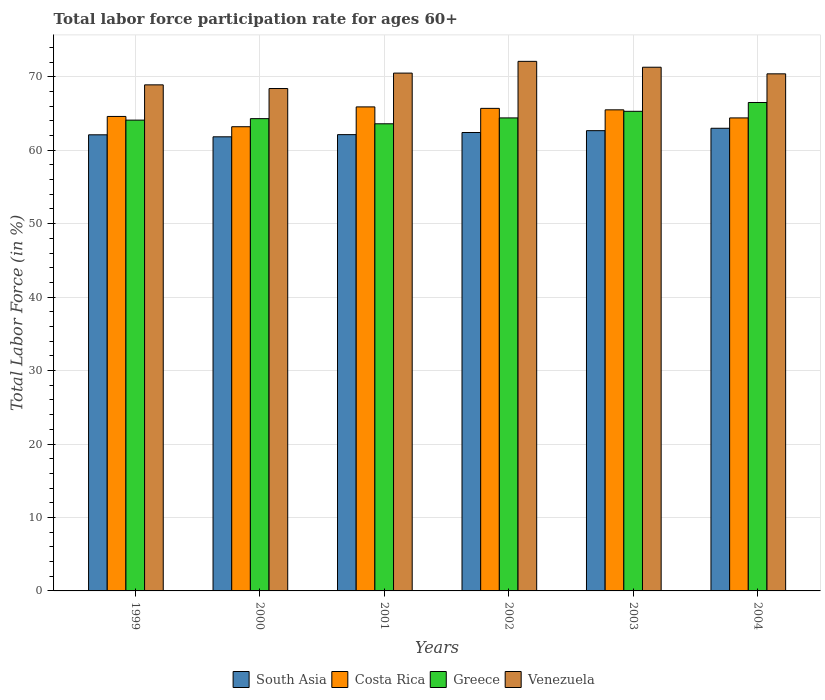Are the number of bars on each tick of the X-axis equal?
Provide a short and direct response. Yes. How many bars are there on the 6th tick from the left?
Your answer should be compact. 4. In how many cases, is the number of bars for a given year not equal to the number of legend labels?
Your answer should be very brief. 0. What is the labor force participation rate in South Asia in 2003?
Your response must be concise. 62.66. Across all years, what is the maximum labor force participation rate in Venezuela?
Your answer should be compact. 72.1. Across all years, what is the minimum labor force participation rate in Costa Rica?
Provide a short and direct response. 63.2. What is the total labor force participation rate in Greece in the graph?
Ensure brevity in your answer.  388.2. What is the difference between the labor force participation rate in South Asia in 2001 and that in 2004?
Ensure brevity in your answer.  -0.87. What is the difference between the labor force participation rate in Greece in 2000 and the labor force participation rate in Venezuela in 2002?
Your answer should be compact. -7.8. What is the average labor force participation rate in South Asia per year?
Offer a very short reply. 62.35. In the year 2004, what is the difference between the labor force participation rate in South Asia and labor force participation rate in Costa Rica?
Make the answer very short. -1.41. In how many years, is the labor force participation rate in Costa Rica greater than 36 %?
Provide a short and direct response. 6. What is the ratio of the labor force participation rate in South Asia in 2001 to that in 2002?
Your answer should be very brief. 1. Is the labor force participation rate in Costa Rica in 2002 less than that in 2003?
Offer a terse response. No. What is the difference between the highest and the second highest labor force participation rate in South Asia?
Give a very brief answer. 0.33. What is the difference between the highest and the lowest labor force participation rate in Costa Rica?
Give a very brief answer. 2.7. In how many years, is the labor force participation rate in Greece greater than the average labor force participation rate in Greece taken over all years?
Keep it short and to the point. 2. Is the sum of the labor force participation rate in South Asia in 2001 and 2003 greater than the maximum labor force participation rate in Costa Rica across all years?
Your answer should be compact. Yes. What does the 4th bar from the left in 2003 represents?
Ensure brevity in your answer.  Venezuela. What does the 1st bar from the right in 2003 represents?
Give a very brief answer. Venezuela. Are all the bars in the graph horizontal?
Your answer should be compact. No. How many years are there in the graph?
Your answer should be very brief. 6. Are the values on the major ticks of Y-axis written in scientific E-notation?
Give a very brief answer. No. Does the graph contain any zero values?
Ensure brevity in your answer.  No. Where does the legend appear in the graph?
Offer a very short reply. Bottom center. What is the title of the graph?
Make the answer very short. Total labor force participation rate for ages 60+. What is the label or title of the X-axis?
Keep it short and to the point. Years. What is the label or title of the Y-axis?
Offer a very short reply. Total Labor Force (in %). What is the Total Labor Force (in %) in South Asia in 1999?
Your response must be concise. 62.1. What is the Total Labor Force (in %) of Costa Rica in 1999?
Give a very brief answer. 64.6. What is the Total Labor Force (in %) in Greece in 1999?
Offer a terse response. 64.1. What is the Total Labor Force (in %) in Venezuela in 1999?
Provide a short and direct response. 68.9. What is the Total Labor Force (in %) of South Asia in 2000?
Your answer should be very brief. 61.83. What is the Total Labor Force (in %) in Costa Rica in 2000?
Make the answer very short. 63.2. What is the Total Labor Force (in %) in Greece in 2000?
Keep it short and to the point. 64.3. What is the Total Labor Force (in %) of Venezuela in 2000?
Your answer should be very brief. 68.4. What is the Total Labor Force (in %) of South Asia in 2001?
Keep it short and to the point. 62.12. What is the Total Labor Force (in %) of Costa Rica in 2001?
Ensure brevity in your answer.  65.9. What is the Total Labor Force (in %) of Greece in 2001?
Keep it short and to the point. 63.6. What is the Total Labor Force (in %) in Venezuela in 2001?
Offer a terse response. 70.5. What is the Total Labor Force (in %) in South Asia in 2002?
Offer a terse response. 62.41. What is the Total Labor Force (in %) of Costa Rica in 2002?
Offer a very short reply. 65.7. What is the Total Labor Force (in %) in Greece in 2002?
Offer a very short reply. 64.4. What is the Total Labor Force (in %) in Venezuela in 2002?
Provide a succinct answer. 72.1. What is the Total Labor Force (in %) of South Asia in 2003?
Offer a very short reply. 62.66. What is the Total Labor Force (in %) in Costa Rica in 2003?
Your answer should be compact. 65.5. What is the Total Labor Force (in %) in Greece in 2003?
Keep it short and to the point. 65.3. What is the Total Labor Force (in %) in Venezuela in 2003?
Make the answer very short. 71.3. What is the Total Labor Force (in %) in South Asia in 2004?
Give a very brief answer. 62.99. What is the Total Labor Force (in %) of Costa Rica in 2004?
Provide a succinct answer. 64.4. What is the Total Labor Force (in %) of Greece in 2004?
Ensure brevity in your answer.  66.5. What is the Total Labor Force (in %) of Venezuela in 2004?
Provide a short and direct response. 70.4. Across all years, what is the maximum Total Labor Force (in %) in South Asia?
Offer a terse response. 62.99. Across all years, what is the maximum Total Labor Force (in %) of Costa Rica?
Ensure brevity in your answer.  65.9. Across all years, what is the maximum Total Labor Force (in %) in Greece?
Offer a terse response. 66.5. Across all years, what is the maximum Total Labor Force (in %) in Venezuela?
Ensure brevity in your answer.  72.1. Across all years, what is the minimum Total Labor Force (in %) of South Asia?
Your answer should be very brief. 61.83. Across all years, what is the minimum Total Labor Force (in %) in Costa Rica?
Give a very brief answer. 63.2. Across all years, what is the minimum Total Labor Force (in %) of Greece?
Ensure brevity in your answer.  63.6. Across all years, what is the minimum Total Labor Force (in %) of Venezuela?
Provide a short and direct response. 68.4. What is the total Total Labor Force (in %) in South Asia in the graph?
Make the answer very short. 374.11. What is the total Total Labor Force (in %) of Costa Rica in the graph?
Provide a succinct answer. 389.3. What is the total Total Labor Force (in %) in Greece in the graph?
Provide a succinct answer. 388.2. What is the total Total Labor Force (in %) of Venezuela in the graph?
Provide a succinct answer. 421.6. What is the difference between the Total Labor Force (in %) in South Asia in 1999 and that in 2000?
Ensure brevity in your answer.  0.27. What is the difference between the Total Labor Force (in %) in Venezuela in 1999 and that in 2000?
Your response must be concise. 0.5. What is the difference between the Total Labor Force (in %) of South Asia in 1999 and that in 2001?
Give a very brief answer. -0.02. What is the difference between the Total Labor Force (in %) in Venezuela in 1999 and that in 2001?
Keep it short and to the point. -1.6. What is the difference between the Total Labor Force (in %) in South Asia in 1999 and that in 2002?
Provide a short and direct response. -0.31. What is the difference between the Total Labor Force (in %) of Costa Rica in 1999 and that in 2002?
Your answer should be compact. -1.1. What is the difference between the Total Labor Force (in %) in Greece in 1999 and that in 2002?
Offer a very short reply. -0.3. What is the difference between the Total Labor Force (in %) in South Asia in 1999 and that in 2003?
Provide a succinct answer. -0.56. What is the difference between the Total Labor Force (in %) in Venezuela in 1999 and that in 2003?
Provide a short and direct response. -2.4. What is the difference between the Total Labor Force (in %) of South Asia in 1999 and that in 2004?
Give a very brief answer. -0.89. What is the difference between the Total Labor Force (in %) in Costa Rica in 1999 and that in 2004?
Offer a terse response. 0.2. What is the difference between the Total Labor Force (in %) of South Asia in 2000 and that in 2001?
Your answer should be very brief. -0.3. What is the difference between the Total Labor Force (in %) of Venezuela in 2000 and that in 2001?
Provide a short and direct response. -2.1. What is the difference between the Total Labor Force (in %) in South Asia in 2000 and that in 2002?
Provide a succinct answer. -0.59. What is the difference between the Total Labor Force (in %) of Costa Rica in 2000 and that in 2002?
Your answer should be very brief. -2.5. What is the difference between the Total Labor Force (in %) of Greece in 2000 and that in 2002?
Provide a succinct answer. -0.1. What is the difference between the Total Labor Force (in %) in Venezuela in 2000 and that in 2002?
Keep it short and to the point. -3.7. What is the difference between the Total Labor Force (in %) in South Asia in 2000 and that in 2003?
Offer a very short reply. -0.84. What is the difference between the Total Labor Force (in %) in Costa Rica in 2000 and that in 2003?
Provide a short and direct response. -2.3. What is the difference between the Total Labor Force (in %) of Venezuela in 2000 and that in 2003?
Your answer should be very brief. -2.9. What is the difference between the Total Labor Force (in %) in South Asia in 2000 and that in 2004?
Your response must be concise. -1.16. What is the difference between the Total Labor Force (in %) of Costa Rica in 2000 and that in 2004?
Give a very brief answer. -1.2. What is the difference between the Total Labor Force (in %) of South Asia in 2001 and that in 2002?
Make the answer very short. -0.29. What is the difference between the Total Labor Force (in %) in Greece in 2001 and that in 2002?
Make the answer very short. -0.8. What is the difference between the Total Labor Force (in %) of Venezuela in 2001 and that in 2002?
Provide a short and direct response. -1.6. What is the difference between the Total Labor Force (in %) of South Asia in 2001 and that in 2003?
Offer a very short reply. -0.54. What is the difference between the Total Labor Force (in %) in Greece in 2001 and that in 2003?
Your answer should be compact. -1.7. What is the difference between the Total Labor Force (in %) in Venezuela in 2001 and that in 2003?
Provide a short and direct response. -0.8. What is the difference between the Total Labor Force (in %) in South Asia in 2001 and that in 2004?
Keep it short and to the point. -0.87. What is the difference between the Total Labor Force (in %) of Costa Rica in 2001 and that in 2004?
Your answer should be compact. 1.5. What is the difference between the Total Labor Force (in %) in Venezuela in 2001 and that in 2004?
Your response must be concise. 0.1. What is the difference between the Total Labor Force (in %) of South Asia in 2002 and that in 2003?
Your answer should be compact. -0.25. What is the difference between the Total Labor Force (in %) in Venezuela in 2002 and that in 2003?
Provide a short and direct response. 0.8. What is the difference between the Total Labor Force (in %) of South Asia in 2002 and that in 2004?
Your answer should be very brief. -0.57. What is the difference between the Total Labor Force (in %) of Greece in 2002 and that in 2004?
Give a very brief answer. -2.1. What is the difference between the Total Labor Force (in %) in Venezuela in 2002 and that in 2004?
Your answer should be very brief. 1.7. What is the difference between the Total Labor Force (in %) of South Asia in 2003 and that in 2004?
Ensure brevity in your answer.  -0.33. What is the difference between the Total Labor Force (in %) of Costa Rica in 2003 and that in 2004?
Keep it short and to the point. 1.1. What is the difference between the Total Labor Force (in %) of South Asia in 1999 and the Total Labor Force (in %) of Costa Rica in 2000?
Keep it short and to the point. -1.1. What is the difference between the Total Labor Force (in %) of South Asia in 1999 and the Total Labor Force (in %) of Greece in 2000?
Keep it short and to the point. -2.2. What is the difference between the Total Labor Force (in %) of South Asia in 1999 and the Total Labor Force (in %) of Venezuela in 2000?
Make the answer very short. -6.3. What is the difference between the Total Labor Force (in %) in Costa Rica in 1999 and the Total Labor Force (in %) in Venezuela in 2000?
Offer a terse response. -3.8. What is the difference between the Total Labor Force (in %) of Greece in 1999 and the Total Labor Force (in %) of Venezuela in 2000?
Your answer should be very brief. -4.3. What is the difference between the Total Labor Force (in %) of South Asia in 1999 and the Total Labor Force (in %) of Costa Rica in 2001?
Ensure brevity in your answer.  -3.8. What is the difference between the Total Labor Force (in %) in South Asia in 1999 and the Total Labor Force (in %) in Greece in 2001?
Offer a terse response. -1.5. What is the difference between the Total Labor Force (in %) in South Asia in 1999 and the Total Labor Force (in %) in Venezuela in 2001?
Keep it short and to the point. -8.4. What is the difference between the Total Labor Force (in %) of Costa Rica in 1999 and the Total Labor Force (in %) of Venezuela in 2001?
Your response must be concise. -5.9. What is the difference between the Total Labor Force (in %) in Greece in 1999 and the Total Labor Force (in %) in Venezuela in 2001?
Ensure brevity in your answer.  -6.4. What is the difference between the Total Labor Force (in %) in South Asia in 1999 and the Total Labor Force (in %) in Costa Rica in 2002?
Offer a very short reply. -3.6. What is the difference between the Total Labor Force (in %) of South Asia in 1999 and the Total Labor Force (in %) of Greece in 2002?
Make the answer very short. -2.3. What is the difference between the Total Labor Force (in %) of South Asia in 1999 and the Total Labor Force (in %) of Venezuela in 2002?
Provide a succinct answer. -10. What is the difference between the Total Labor Force (in %) of South Asia in 1999 and the Total Labor Force (in %) of Costa Rica in 2003?
Provide a short and direct response. -3.4. What is the difference between the Total Labor Force (in %) of South Asia in 1999 and the Total Labor Force (in %) of Greece in 2003?
Offer a terse response. -3.2. What is the difference between the Total Labor Force (in %) in South Asia in 1999 and the Total Labor Force (in %) in Venezuela in 2003?
Your answer should be compact. -9.2. What is the difference between the Total Labor Force (in %) in South Asia in 1999 and the Total Labor Force (in %) in Costa Rica in 2004?
Offer a terse response. -2.3. What is the difference between the Total Labor Force (in %) of South Asia in 1999 and the Total Labor Force (in %) of Greece in 2004?
Give a very brief answer. -4.4. What is the difference between the Total Labor Force (in %) in South Asia in 1999 and the Total Labor Force (in %) in Venezuela in 2004?
Offer a terse response. -8.3. What is the difference between the Total Labor Force (in %) of Costa Rica in 1999 and the Total Labor Force (in %) of Greece in 2004?
Your answer should be very brief. -1.9. What is the difference between the Total Labor Force (in %) of Costa Rica in 1999 and the Total Labor Force (in %) of Venezuela in 2004?
Ensure brevity in your answer.  -5.8. What is the difference between the Total Labor Force (in %) in Greece in 1999 and the Total Labor Force (in %) in Venezuela in 2004?
Your answer should be very brief. -6.3. What is the difference between the Total Labor Force (in %) in South Asia in 2000 and the Total Labor Force (in %) in Costa Rica in 2001?
Make the answer very short. -4.07. What is the difference between the Total Labor Force (in %) of South Asia in 2000 and the Total Labor Force (in %) of Greece in 2001?
Provide a short and direct response. -1.77. What is the difference between the Total Labor Force (in %) in South Asia in 2000 and the Total Labor Force (in %) in Venezuela in 2001?
Offer a terse response. -8.67. What is the difference between the Total Labor Force (in %) in Costa Rica in 2000 and the Total Labor Force (in %) in Greece in 2001?
Provide a succinct answer. -0.4. What is the difference between the Total Labor Force (in %) in Costa Rica in 2000 and the Total Labor Force (in %) in Venezuela in 2001?
Offer a very short reply. -7.3. What is the difference between the Total Labor Force (in %) of South Asia in 2000 and the Total Labor Force (in %) of Costa Rica in 2002?
Offer a terse response. -3.87. What is the difference between the Total Labor Force (in %) in South Asia in 2000 and the Total Labor Force (in %) in Greece in 2002?
Your answer should be very brief. -2.57. What is the difference between the Total Labor Force (in %) in South Asia in 2000 and the Total Labor Force (in %) in Venezuela in 2002?
Your answer should be compact. -10.27. What is the difference between the Total Labor Force (in %) in Costa Rica in 2000 and the Total Labor Force (in %) in Greece in 2002?
Ensure brevity in your answer.  -1.2. What is the difference between the Total Labor Force (in %) of Costa Rica in 2000 and the Total Labor Force (in %) of Venezuela in 2002?
Offer a terse response. -8.9. What is the difference between the Total Labor Force (in %) in South Asia in 2000 and the Total Labor Force (in %) in Costa Rica in 2003?
Offer a terse response. -3.67. What is the difference between the Total Labor Force (in %) in South Asia in 2000 and the Total Labor Force (in %) in Greece in 2003?
Ensure brevity in your answer.  -3.47. What is the difference between the Total Labor Force (in %) in South Asia in 2000 and the Total Labor Force (in %) in Venezuela in 2003?
Your answer should be very brief. -9.47. What is the difference between the Total Labor Force (in %) of Costa Rica in 2000 and the Total Labor Force (in %) of Greece in 2003?
Offer a very short reply. -2.1. What is the difference between the Total Labor Force (in %) of Greece in 2000 and the Total Labor Force (in %) of Venezuela in 2003?
Offer a very short reply. -7. What is the difference between the Total Labor Force (in %) of South Asia in 2000 and the Total Labor Force (in %) of Costa Rica in 2004?
Make the answer very short. -2.57. What is the difference between the Total Labor Force (in %) in South Asia in 2000 and the Total Labor Force (in %) in Greece in 2004?
Keep it short and to the point. -4.67. What is the difference between the Total Labor Force (in %) of South Asia in 2000 and the Total Labor Force (in %) of Venezuela in 2004?
Your response must be concise. -8.57. What is the difference between the Total Labor Force (in %) of Greece in 2000 and the Total Labor Force (in %) of Venezuela in 2004?
Offer a very short reply. -6.1. What is the difference between the Total Labor Force (in %) in South Asia in 2001 and the Total Labor Force (in %) in Costa Rica in 2002?
Keep it short and to the point. -3.58. What is the difference between the Total Labor Force (in %) in South Asia in 2001 and the Total Labor Force (in %) in Greece in 2002?
Make the answer very short. -2.28. What is the difference between the Total Labor Force (in %) in South Asia in 2001 and the Total Labor Force (in %) in Venezuela in 2002?
Make the answer very short. -9.98. What is the difference between the Total Labor Force (in %) of Costa Rica in 2001 and the Total Labor Force (in %) of Venezuela in 2002?
Give a very brief answer. -6.2. What is the difference between the Total Labor Force (in %) in Greece in 2001 and the Total Labor Force (in %) in Venezuela in 2002?
Give a very brief answer. -8.5. What is the difference between the Total Labor Force (in %) of South Asia in 2001 and the Total Labor Force (in %) of Costa Rica in 2003?
Your answer should be compact. -3.38. What is the difference between the Total Labor Force (in %) in South Asia in 2001 and the Total Labor Force (in %) in Greece in 2003?
Make the answer very short. -3.18. What is the difference between the Total Labor Force (in %) of South Asia in 2001 and the Total Labor Force (in %) of Venezuela in 2003?
Your response must be concise. -9.18. What is the difference between the Total Labor Force (in %) in Costa Rica in 2001 and the Total Labor Force (in %) in Greece in 2003?
Offer a very short reply. 0.6. What is the difference between the Total Labor Force (in %) of South Asia in 2001 and the Total Labor Force (in %) of Costa Rica in 2004?
Your answer should be very brief. -2.28. What is the difference between the Total Labor Force (in %) of South Asia in 2001 and the Total Labor Force (in %) of Greece in 2004?
Offer a terse response. -4.38. What is the difference between the Total Labor Force (in %) of South Asia in 2001 and the Total Labor Force (in %) of Venezuela in 2004?
Your answer should be very brief. -8.28. What is the difference between the Total Labor Force (in %) in Costa Rica in 2001 and the Total Labor Force (in %) in Greece in 2004?
Your answer should be compact. -0.6. What is the difference between the Total Labor Force (in %) in Costa Rica in 2001 and the Total Labor Force (in %) in Venezuela in 2004?
Your answer should be very brief. -4.5. What is the difference between the Total Labor Force (in %) in South Asia in 2002 and the Total Labor Force (in %) in Costa Rica in 2003?
Offer a terse response. -3.09. What is the difference between the Total Labor Force (in %) in South Asia in 2002 and the Total Labor Force (in %) in Greece in 2003?
Provide a succinct answer. -2.89. What is the difference between the Total Labor Force (in %) of South Asia in 2002 and the Total Labor Force (in %) of Venezuela in 2003?
Your answer should be compact. -8.89. What is the difference between the Total Labor Force (in %) in Costa Rica in 2002 and the Total Labor Force (in %) in Greece in 2003?
Make the answer very short. 0.4. What is the difference between the Total Labor Force (in %) of Costa Rica in 2002 and the Total Labor Force (in %) of Venezuela in 2003?
Your answer should be very brief. -5.6. What is the difference between the Total Labor Force (in %) in Greece in 2002 and the Total Labor Force (in %) in Venezuela in 2003?
Offer a very short reply. -6.9. What is the difference between the Total Labor Force (in %) of South Asia in 2002 and the Total Labor Force (in %) of Costa Rica in 2004?
Ensure brevity in your answer.  -1.99. What is the difference between the Total Labor Force (in %) in South Asia in 2002 and the Total Labor Force (in %) in Greece in 2004?
Offer a terse response. -4.09. What is the difference between the Total Labor Force (in %) of South Asia in 2002 and the Total Labor Force (in %) of Venezuela in 2004?
Make the answer very short. -7.99. What is the difference between the Total Labor Force (in %) of Costa Rica in 2002 and the Total Labor Force (in %) of Greece in 2004?
Your response must be concise. -0.8. What is the difference between the Total Labor Force (in %) in South Asia in 2003 and the Total Labor Force (in %) in Costa Rica in 2004?
Offer a very short reply. -1.74. What is the difference between the Total Labor Force (in %) in South Asia in 2003 and the Total Labor Force (in %) in Greece in 2004?
Offer a terse response. -3.84. What is the difference between the Total Labor Force (in %) in South Asia in 2003 and the Total Labor Force (in %) in Venezuela in 2004?
Your response must be concise. -7.74. What is the difference between the Total Labor Force (in %) of Costa Rica in 2003 and the Total Labor Force (in %) of Venezuela in 2004?
Provide a succinct answer. -4.9. What is the difference between the Total Labor Force (in %) of Greece in 2003 and the Total Labor Force (in %) of Venezuela in 2004?
Offer a terse response. -5.1. What is the average Total Labor Force (in %) in South Asia per year?
Keep it short and to the point. 62.35. What is the average Total Labor Force (in %) in Costa Rica per year?
Your answer should be compact. 64.88. What is the average Total Labor Force (in %) in Greece per year?
Your response must be concise. 64.7. What is the average Total Labor Force (in %) in Venezuela per year?
Your answer should be very brief. 70.27. In the year 1999, what is the difference between the Total Labor Force (in %) of South Asia and Total Labor Force (in %) of Costa Rica?
Your answer should be very brief. -2.5. In the year 1999, what is the difference between the Total Labor Force (in %) in South Asia and Total Labor Force (in %) in Greece?
Provide a short and direct response. -2. In the year 1999, what is the difference between the Total Labor Force (in %) in South Asia and Total Labor Force (in %) in Venezuela?
Offer a terse response. -6.8. In the year 1999, what is the difference between the Total Labor Force (in %) in Costa Rica and Total Labor Force (in %) in Greece?
Provide a succinct answer. 0.5. In the year 1999, what is the difference between the Total Labor Force (in %) in Greece and Total Labor Force (in %) in Venezuela?
Keep it short and to the point. -4.8. In the year 2000, what is the difference between the Total Labor Force (in %) in South Asia and Total Labor Force (in %) in Costa Rica?
Offer a very short reply. -1.37. In the year 2000, what is the difference between the Total Labor Force (in %) of South Asia and Total Labor Force (in %) of Greece?
Your answer should be very brief. -2.47. In the year 2000, what is the difference between the Total Labor Force (in %) in South Asia and Total Labor Force (in %) in Venezuela?
Offer a terse response. -6.57. In the year 2000, what is the difference between the Total Labor Force (in %) of Costa Rica and Total Labor Force (in %) of Venezuela?
Your response must be concise. -5.2. In the year 2001, what is the difference between the Total Labor Force (in %) of South Asia and Total Labor Force (in %) of Costa Rica?
Your answer should be compact. -3.78. In the year 2001, what is the difference between the Total Labor Force (in %) of South Asia and Total Labor Force (in %) of Greece?
Your response must be concise. -1.48. In the year 2001, what is the difference between the Total Labor Force (in %) of South Asia and Total Labor Force (in %) of Venezuela?
Give a very brief answer. -8.38. In the year 2001, what is the difference between the Total Labor Force (in %) of Costa Rica and Total Labor Force (in %) of Venezuela?
Offer a very short reply. -4.6. In the year 2002, what is the difference between the Total Labor Force (in %) in South Asia and Total Labor Force (in %) in Costa Rica?
Your answer should be compact. -3.29. In the year 2002, what is the difference between the Total Labor Force (in %) in South Asia and Total Labor Force (in %) in Greece?
Keep it short and to the point. -1.99. In the year 2002, what is the difference between the Total Labor Force (in %) of South Asia and Total Labor Force (in %) of Venezuela?
Offer a terse response. -9.69. In the year 2003, what is the difference between the Total Labor Force (in %) in South Asia and Total Labor Force (in %) in Costa Rica?
Your answer should be very brief. -2.84. In the year 2003, what is the difference between the Total Labor Force (in %) of South Asia and Total Labor Force (in %) of Greece?
Your answer should be very brief. -2.64. In the year 2003, what is the difference between the Total Labor Force (in %) in South Asia and Total Labor Force (in %) in Venezuela?
Make the answer very short. -8.64. In the year 2003, what is the difference between the Total Labor Force (in %) of Costa Rica and Total Labor Force (in %) of Greece?
Your response must be concise. 0.2. In the year 2003, what is the difference between the Total Labor Force (in %) of Costa Rica and Total Labor Force (in %) of Venezuela?
Offer a terse response. -5.8. In the year 2004, what is the difference between the Total Labor Force (in %) of South Asia and Total Labor Force (in %) of Costa Rica?
Offer a terse response. -1.41. In the year 2004, what is the difference between the Total Labor Force (in %) of South Asia and Total Labor Force (in %) of Greece?
Keep it short and to the point. -3.51. In the year 2004, what is the difference between the Total Labor Force (in %) in South Asia and Total Labor Force (in %) in Venezuela?
Provide a short and direct response. -7.41. In the year 2004, what is the difference between the Total Labor Force (in %) in Greece and Total Labor Force (in %) in Venezuela?
Ensure brevity in your answer.  -3.9. What is the ratio of the Total Labor Force (in %) of Costa Rica in 1999 to that in 2000?
Provide a succinct answer. 1.02. What is the ratio of the Total Labor Force (in %) in Venezuela in 1999 to that in 2000?
Offer a terse response. 1.01. What is the ratio of the Total Labor Force (in %) in Costa Rica in 1999 to that in 2001?
Offer a very short reply. 0.98. What is the ratio of the Total Labor Force (in %) in Greece in 1999 to that in 2001?
Offer a very short reply. 1.01. What is the ratio of the Total Labor Force (in %) of Venezuela in 1999 to that in 2001?
Your answer should be compact. 0.98. What is the ratio of the Total Labor Force (in %) in South Asia in 1999 to that in 2002?
Keep it short and to the point. 0.99. What is the ratio of the Total Labor Force (in %) of Costa Rica in 1999 to that in 2002?
Ensure brevity in your answer.  0.98. What is the ratio of the Total Labor Force (in %) of Venezuela in 1999 to that in 2002?
Your response must be concise. 0.96. What is the ratio of the Total Labor Force (in %) of South Asia in 1999 to that in 2003?
Provide a short and direct response. 0.99. What is the ratio of the Total Labor Force (in %) in Costa Rica in 1999 to that in 2003?
Offer a terse response. 0.99. What is the ratio of the Total Labor Force (in %) of Greece in 1999 to that in 2003?
Your answer should be compact. 0.98. What is the ratio of the Total Labor Force (in %) of Venezuela in 1999 to that in 2003?
Make the answer very short. 0.97. What is the ratio of the Total Labor Force (in %) in South Asia in 1999 to that in 2004?
Your answer should be compact. 0.99. What is the ratio of the Total Labor Force (in %) of Greece in 1999 to that in 2004?
Your response must be concise. 0.96. What is the ratio of the Total Labor Force (in %) in Venezuela in 1999 to that in 2004?
Your response must be concise. 0.98. What is the ratio of the Total Labor Force (in %) in Costa Rica in 2000 to that in 2001?
Your answer should be compact. 0.96. What is the ratio of the Total Labor Force (in %) in Venezuela in 2000 to that in 2001?
Give a very brief answer. 0.97. What is the ratio of the Total Labor Force (in %) in South Asia in 2000 to that in 2002?
Provide a short and direct response. 0.99. What is the ratio of the Total Labor Force (in %) of Costa Rica in 2000 to that in 2002?
Ensure brevity in your answer.  0.96. What is the ratio of the Total Labor Force (in %) in Venezuela in 2000 to that in 2002?
Provide a succinct answer. 0.95. What is the ratio of the Total Labor Force (in %) in South Asia in 2000 to that in 2003?
Your answer should be very brief. 0.99. What is the ratio of the Total Labor Force (in %) in Costa Rica in 2000 to that in 2003?
Provide a short and direct response. 0.96. What is the ratio of the Total Labor Force (in %) in Greece in 2000 to that in 2003?
Your answer should be compact. 0.98. What is the ratio of the Total Labor Force (in %) of Venezuela in 2000 to that in 2003?
Provide a short and direct response. 0.96. What is the ratio of the Total Labor Force (in %) in South Asia in 2000 to that in 2004?
Give a very brief answer. 0.98. What is the ratio of the Total Labor Force (in %) in Costa Rica in 2000 to that in 2004?
Make the answer very short. 0.98. What is the ratio of the Total Labor Force (in %) of Greece in 2000 to that in 2004?
Keep it short and to the point. 0.97. What is the ratio of the Total Labor Force (in %) in Venezuela in 2000 to that in 2004?
Provide a succinct answer. 0.97. What is the ratio of the Total Labor Force (in %) of Greece in 2001 to that in 2002?
Your answer should be compact. 0.99. What is the ratio of the Total Labor Force (in %) of Venezuela in 2001 to that in 2002?
Give a very brief answer. 0.98. What is the ratio of the Total Labor Force (in %) of Costa Rica in 2001 to that in 2003?
Offer a terse response. 1.01. What is the ratio of the Total Labor Force (in %) in Greece in 2001 to that in 2003?
Provide a succinct answer. 0.97. What is the ratio of the Total Labor Force (in %) of Venezuela in 2001 to that in 2003?
Provide a succinct answer. 0.99. What is the ratio of the Total Labor Force (in %) in South Asia in 2001 to that in 2004?
Keep it short and to the point. 0.99. What is the ratio of the Total Labor Force (in %) of Costa Rica in 2001 to that in 2004?
Offer a terse response. 1.02. What is the ratio of the Total Labor Force (in %) in Greece in 2001 to that in 2004?
Keep it short and to the point. 0.96. What is the ratio of the Total Labor Force (in %) of Venezuela in 2001 to that in 2004?
Offer a very short reply. 1. What is the ratio of the Total Labor Force (in %) in Greece in 2002 to that in 2003?
Ensure brevity in your answer.  0.99. What is the ratio of the Total Labor Force (in %) in Venezuela in 2002 to that in 2003?
Offer a very short reply. 1.01. What is the ratio of the Total Labor Force (in %) in South Asia in 2002 to that in 2004?
Offer a very short reply. 0.99. What is the ratio of the Total Labor Force (in %) in Costa Rica in 2002 to that in 2004?
Offer a terse response. 1.02. What is the ratio of the Total Labor Force (in %) of Greece in 2002 to that in 2004?
Your answer should be compact. 0.97. What is the ratio of the Total Labor Force (in %) of Venezuela in 2002 to that in 2004?
Ensure brevity in your answer.  1.02. What is the ratio of the Total Labor Force (in %) in Costa Rica in 2003 to that in 2004?
Make the answer very short. 1.02. What is the ratio of the Total Labor Force (in %) in Venezuela in 2003 to that in 2004?
Your response must be concise. 1.01. What is the difference between the highest and the second highest Total Labor Force (in %) in South Asia?
Give a very brief answer. 0.33. What is the difference between the highest and the second highest Total Labor Force (in %) in Greece?
Provide a short and direct response. 1.2. What is the difference between the highest and the lowest Total Labor Force (in %) in South Asia?
Provide a short and direct response. 1.16. What is the difference between the highest and the lowest Total Labor Force (in %) of Venezuela?
Your answer should be compact. 3.7. 